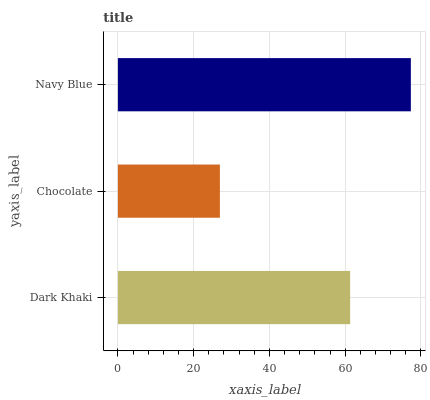Is Chocolate the minimum?
Answer yes or no. Yes. Is Navy Blue the maximum?
Answer yes or no. Yes. Is Navy Blue the minimum?
Answer yes or no. No. Is Chocolate the maximum?
Answer yes or no. No. Is Navy Blue greater than Chocolate?
Answer yes or no. Yes. Is Chocolate less than Navy Blue?
Answer yes or no. Yes. Is Chocolate greater than Navy Blue?
Answer yes or no. No. Is Navy Blue less than Chocolate?
Answer yes or no. No. Is Dark Khaki the high median?
Answer yes or no. Yes. Is Dark Khaki the low median?
Answer yes or no. Yes. Is Chocolate the high median?
Answer yes or no. No. Is Navy Blue the low median?
Answer yes or no. No. 